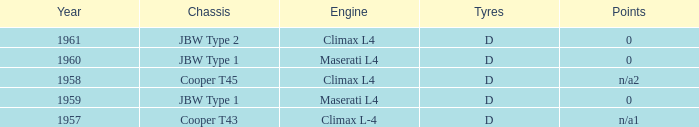What engine was in the year of 1961? Climax L4. 